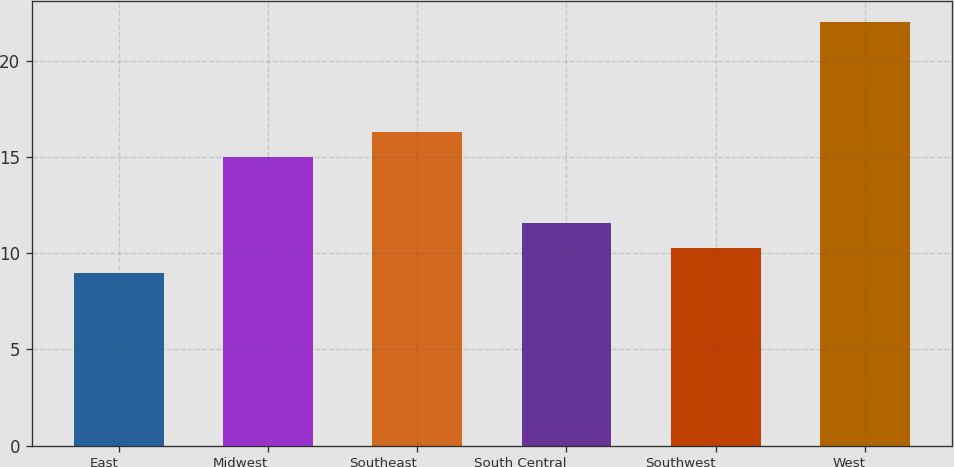Convert chart. <chart><loc_0><loc_0><loc_500><loc_500><bar_chart><fcel>East<fcel>Midwest<fcel>Southeast<fcel>South Central<fcel>Southwest<fcel>West<nl><fcel>9<fcel>15<fcel>16.3<fcel>11.6<fcel>10.3<fcel>22<nl></chart> 